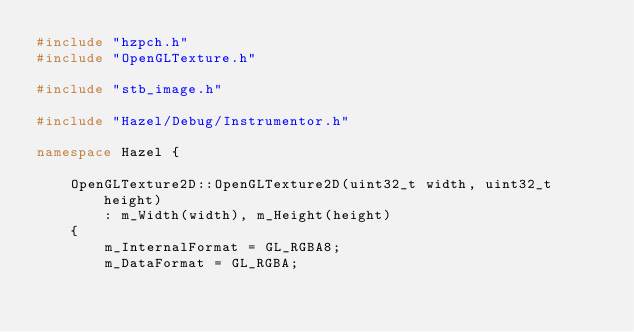Convert code to text. <code><loc_0><loc_0><loc_500><loc_500><_C++_>#include "hzpch.h"
#include "OpenGLTexture.h"

#include "stb_image.h"

#include "Hazel/Debug/Instrumentor.h"

namespace Hazel {

	OpenGLTexture2D::OpenGLTexture2D(uint32_t width, uint32_t height)
		: m_Width(width), m_Height(height)
	{
		m_InternalFormat = GL_RGBA8;
		m_DataFormat = GL_RGBA;
		</code> 